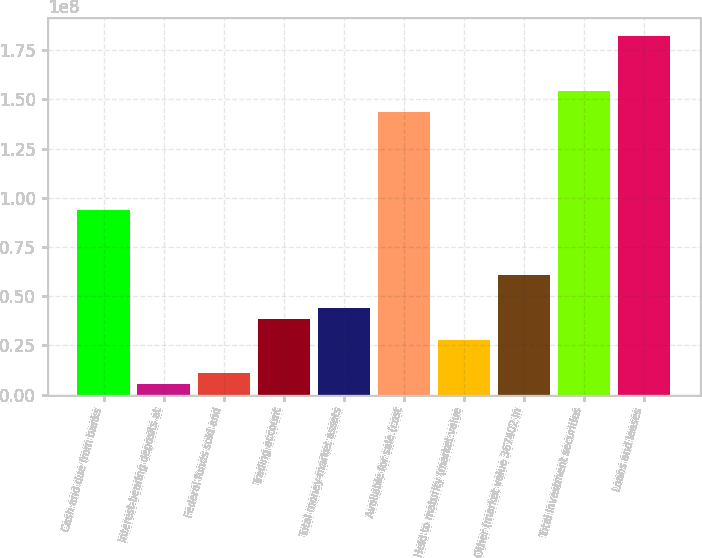Convert chart to OTSL. <chart><loc_0><loc_0><loc_500><loc_500><bar_chart><fcel>Cash and due from banks<fcel>Interest-bearing deposits at<fcel>Federal funds sold and<fcel>Trading account<fcel>Total money-market assets<fcel>Available for sale (cost<fcel>Held to maturity (market value<fcel>Other (market value 367402 in<fcel>Total investment securities<fcel>Loans and leases<nl><fcel>9.37451e+07<fcel>5.51947e+06<fcel>1.10336e+07<fcel>3.86041e+07<fcel>4.41182e+07<fcel>1.43372e+08<fcel>2.75759e+07<fcel>6.06605e+07<fcel>1.544e+08<fcel>1.81971e+08<nl></chart> 